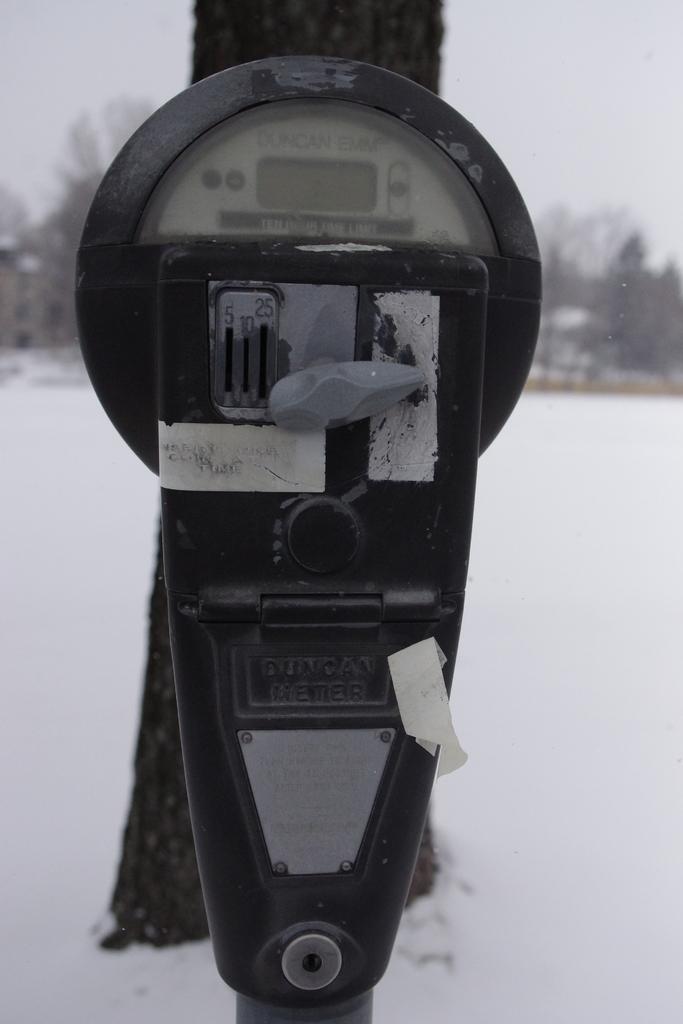Which company manufactured this meter?
Your answer should be very brief. Duncan. 